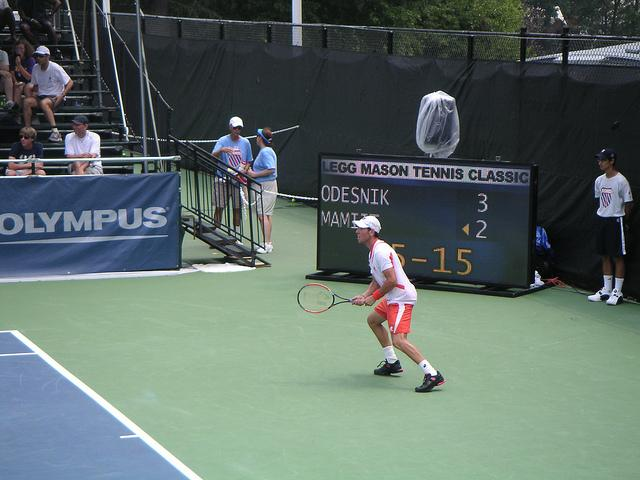What type of tennis game is being played here? singles 